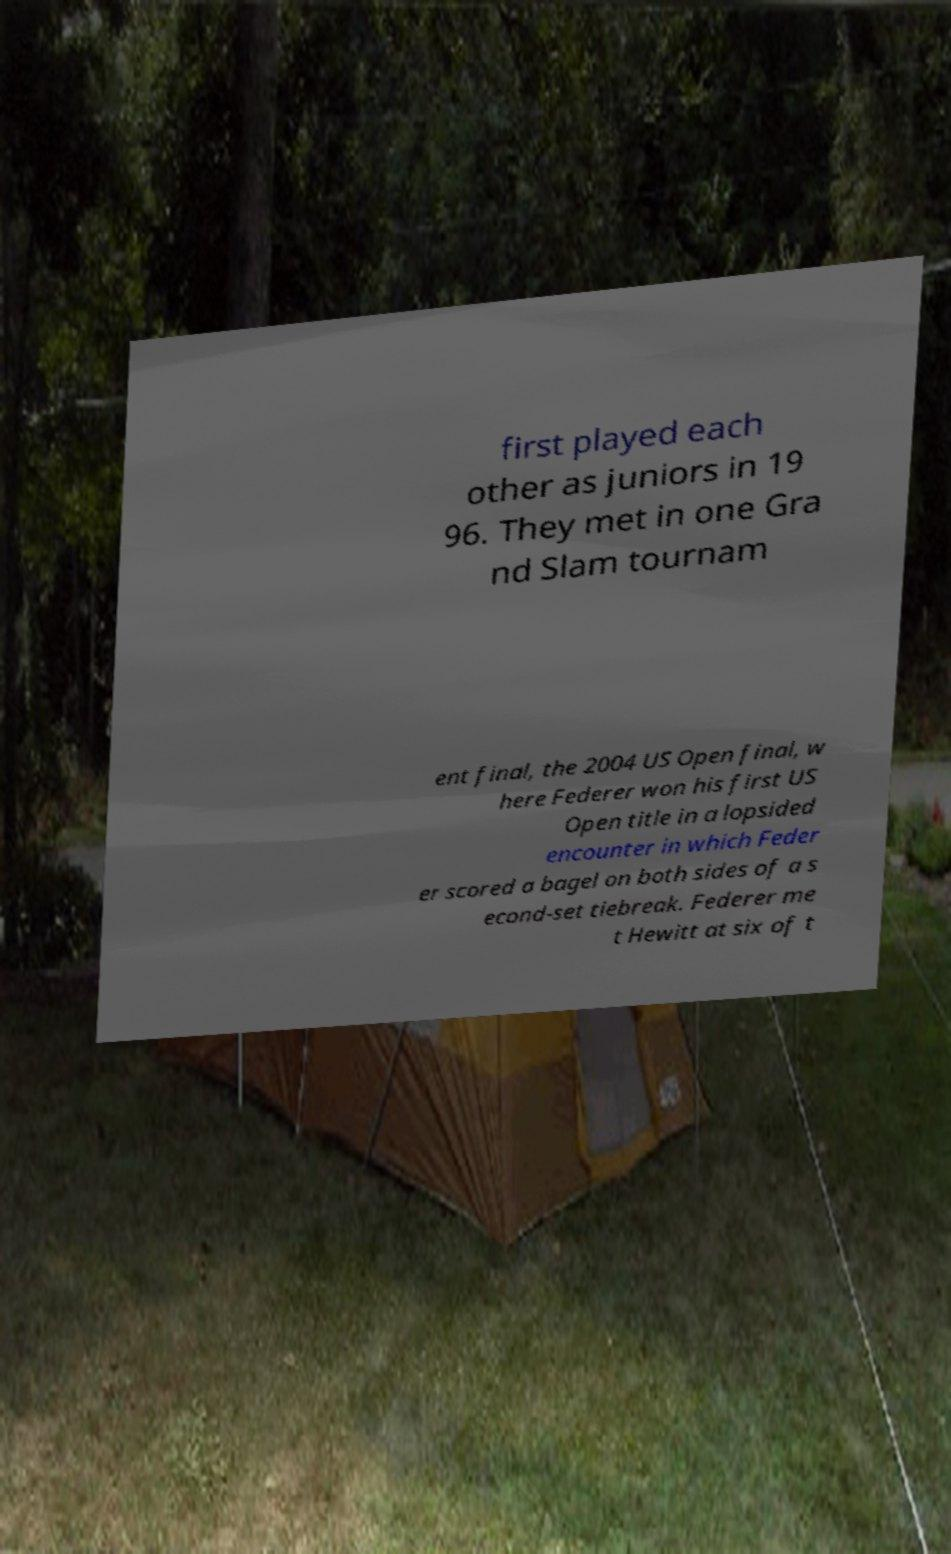Please identify and transcribe the text found in this image. first played each other as juniors in 19 96. They met in one Gra nd Slam tournam ent final, the 2004 US Open final, w here Federer won his first US Open title in a lopsided encounter in which Feder er scored a bagel on both sides of a s econd-set tiebreak. Federer me t Hewitt at six of t 